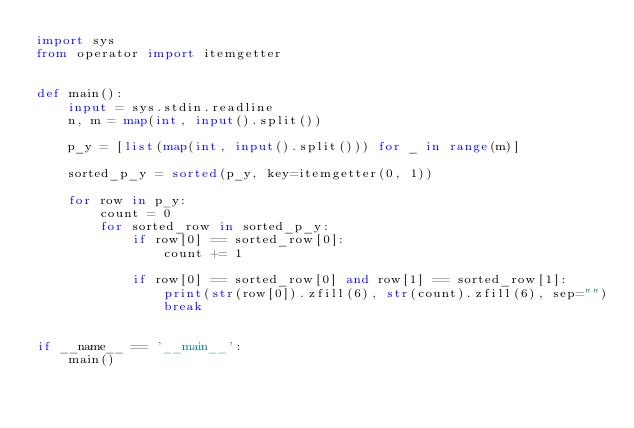Convert code to text. <code><loc_0><loc_0><loc_500><loc_500><_Python_>import sys
from operator import itemgetter


def main():
    input = sys.stdin.readline
    n, m = map(int, input().split())

    p_y = [list(map(int, input().split())) for _ in range(m)]

    sorted_p_y = sorted(p_y, key=itemgetter(0, 1))

    for row in p_y:
        count = 0
        for sorted_row in sorted_p_y:
            if row[0] == sorted_row[0]:
                count += 1

            if row[0] == sorted_row[0] and row[1] == sorted_row[1]:
                print(str(row[0]).zfill(6), str(count).zfill(6), sep="")
                break


if __name__ == '__main__':
    main()
</code> 